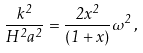Convert formula to latex. <formula><loc_0><loc_0><loc_500><loc_500>\frac { k ^ { 2 } } { H ^ { 2 } a ^ { 2 } } = \frac { 2 x ^ { 2 } } { ( 1 + x ) } \omega ^ { 2 } \, ,</formula> 